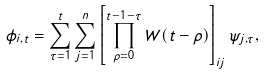<formula> <loc_0><loc_0><loc_500><loc_500>\phi _ { i , t } = \sum _ { \tau = 1 } ^ { t } \sum _ { j = 1 } ^ { n } \left [ \prod _ { \rho = 0 } ^ { t - 1 - \tau } W ( t - \rho ) \right ] _ { i j } \psi _ { j , \tau } ,</formula> 